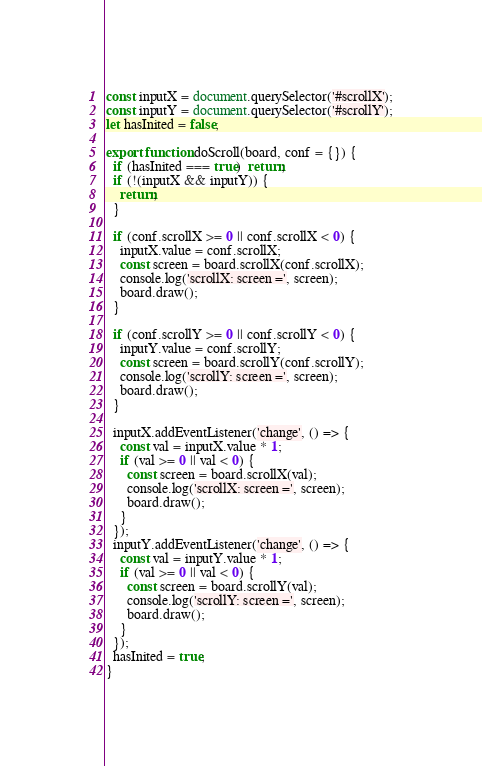Convert code to text. <code><loc_0><loc_0><loc_500><loc_500><_JavaScript_>const inputX = document.querySelector('#scrollX');
const inputY = document.querySelector('#scrollY');
let hasInited = false;

export function doScroll(board, conf = {}) {
  if (hasInited === true)  return;
  if (!(inputX && inputY)) {
    return;
  }
  
  if (conf.scrollX >= 0 || conf.scrollX < 0) {
    inputX.value = conf.scrollX;
    const screen = board.scrollX(conf.scrollX);
    console.log('scrollX: screen =', screen);
    board.draw();
  }

  if (conf.scrollY >= 0 || conf.scrollY < 0) {
    inputY.value = conf.scrollY;
    const screen = board.scrollY(conf.scrollY);
    console.log('scrollY: screen =', screen);
    board.draw();
  }

  inputX.addEventListener('change', () => {
    const val = inputX.value * 1;
    if (val >= 0 || val < 0) {
      const screen = board.scrollX(val);
      console.log('scrollX: screen =', screen);
      board.draw();
    }
  });
  inputY.addEventListener('change', () => {
    const val = inputY.value * 1;
    if (val >= 0 || val < 0) {
      const screen = board.scrollY(val);
      console.log('scrollY: screen =', screen);
      board.draw();
    }
  });
  hasInited = true;
}</code> 